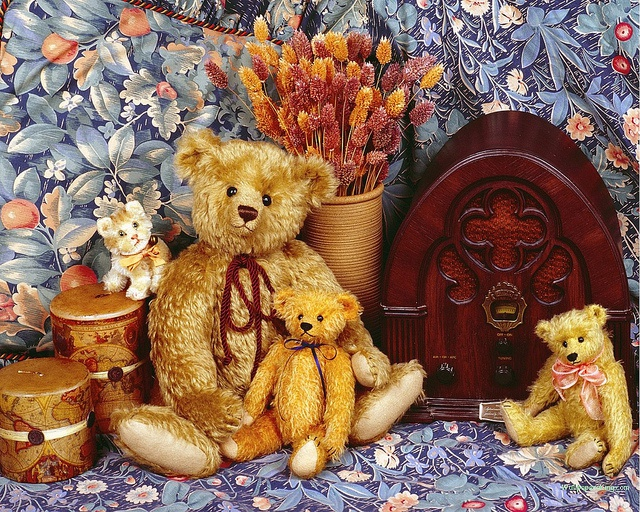Describe the objects in this image and their specific colors. I can see teddy bear in lightgray, olive, tan, and maroon tones, teddy bear in lightgray, orange, red, and gold tones, teddy bear in lightgray, tan, olive, and khaki tones, vase in lightgray, brown, maroon, tan, and black tones, and teddy bear in lightgray, khaki, beige, tan, and red tones in this image. 